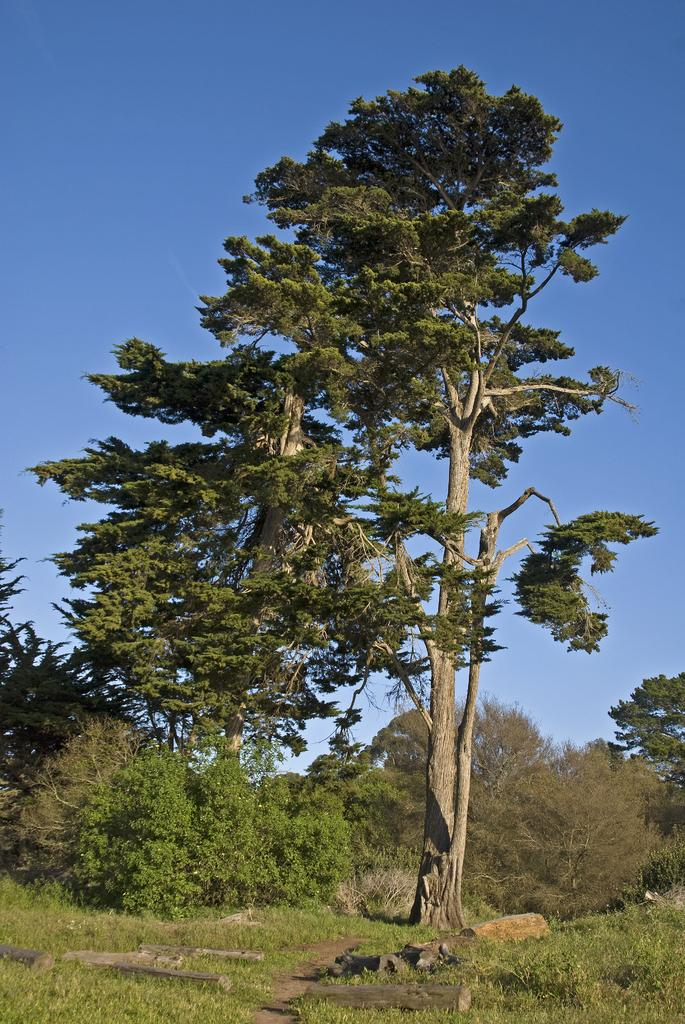What type of surface can be seen in the image? The ground is visible in the image. What type of vegetation is present in the image? There is grass in the image. What else can be seen in the image besides the ground and grass? There are trees in the image. What is visible above the trees and grass in the image? The sky is visible in the image. What letter can be seen on the tree in the image? There are no letters present on the trees in the image. What type of club is visible in the image? There is no club present in the image. 